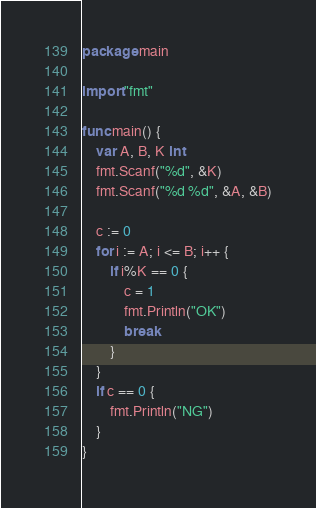Convert code to text. <code><loc_0><loc_0><loc_500><loc_500><_Go_>package main

import "fmt"

func main() {
	var A, B, K int
	fmt.Scanf("%d", &K)
	fmt.Scanf("%d %d", &A, &B)

	c := 0
	for i := A; i <= B; i++ {
		if i%K == 0 {
			c = 1
			fmt.Println("OK")
			break
		}
	}
	if c == 0 {
		fmt.Println("NG")
	}
}</code> 